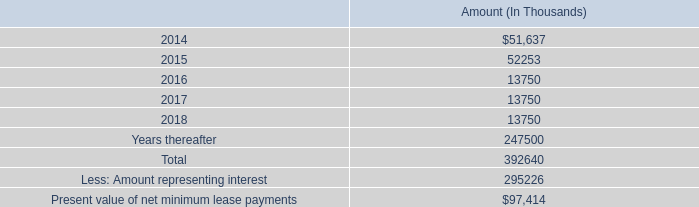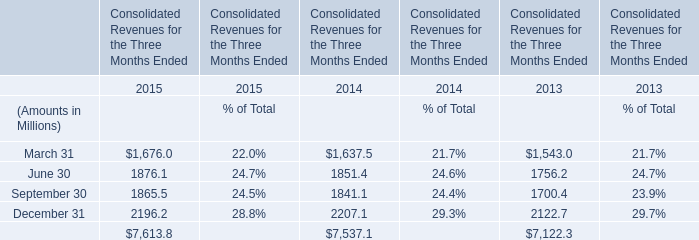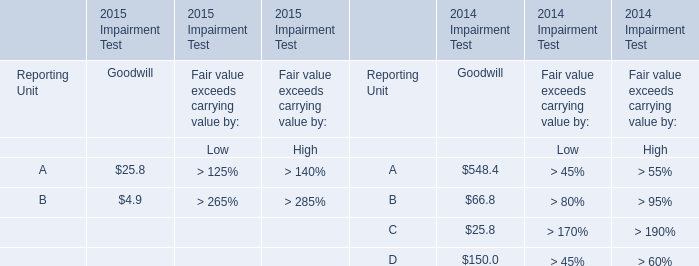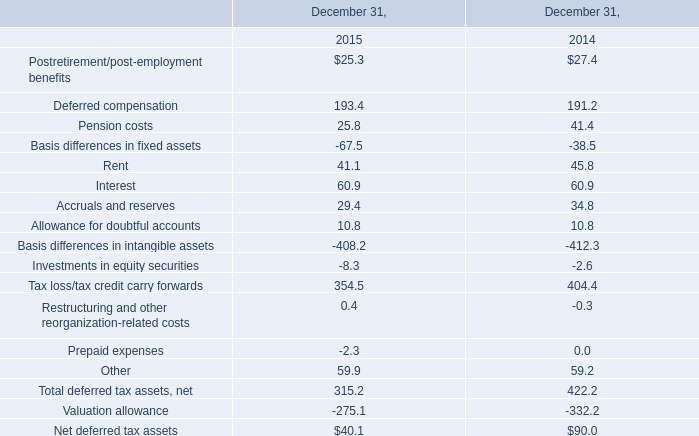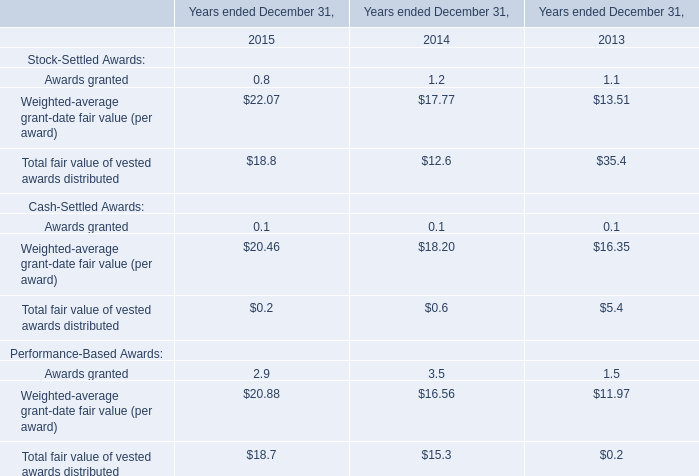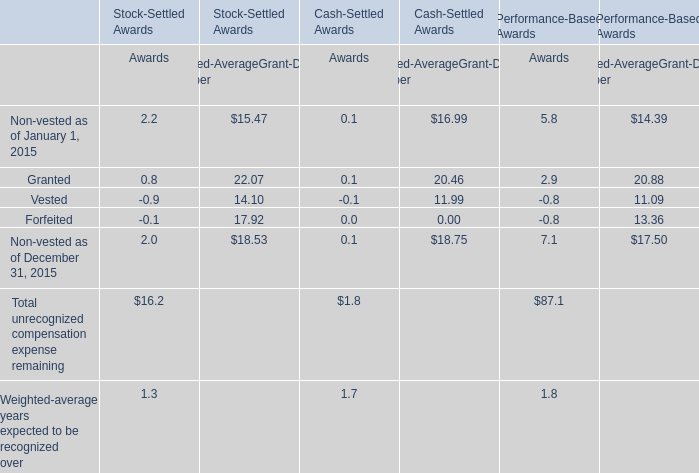Which year does the Total fair value of vested awards distributed for Stock-Settled Awards rank first? 
Answer: 2013. 